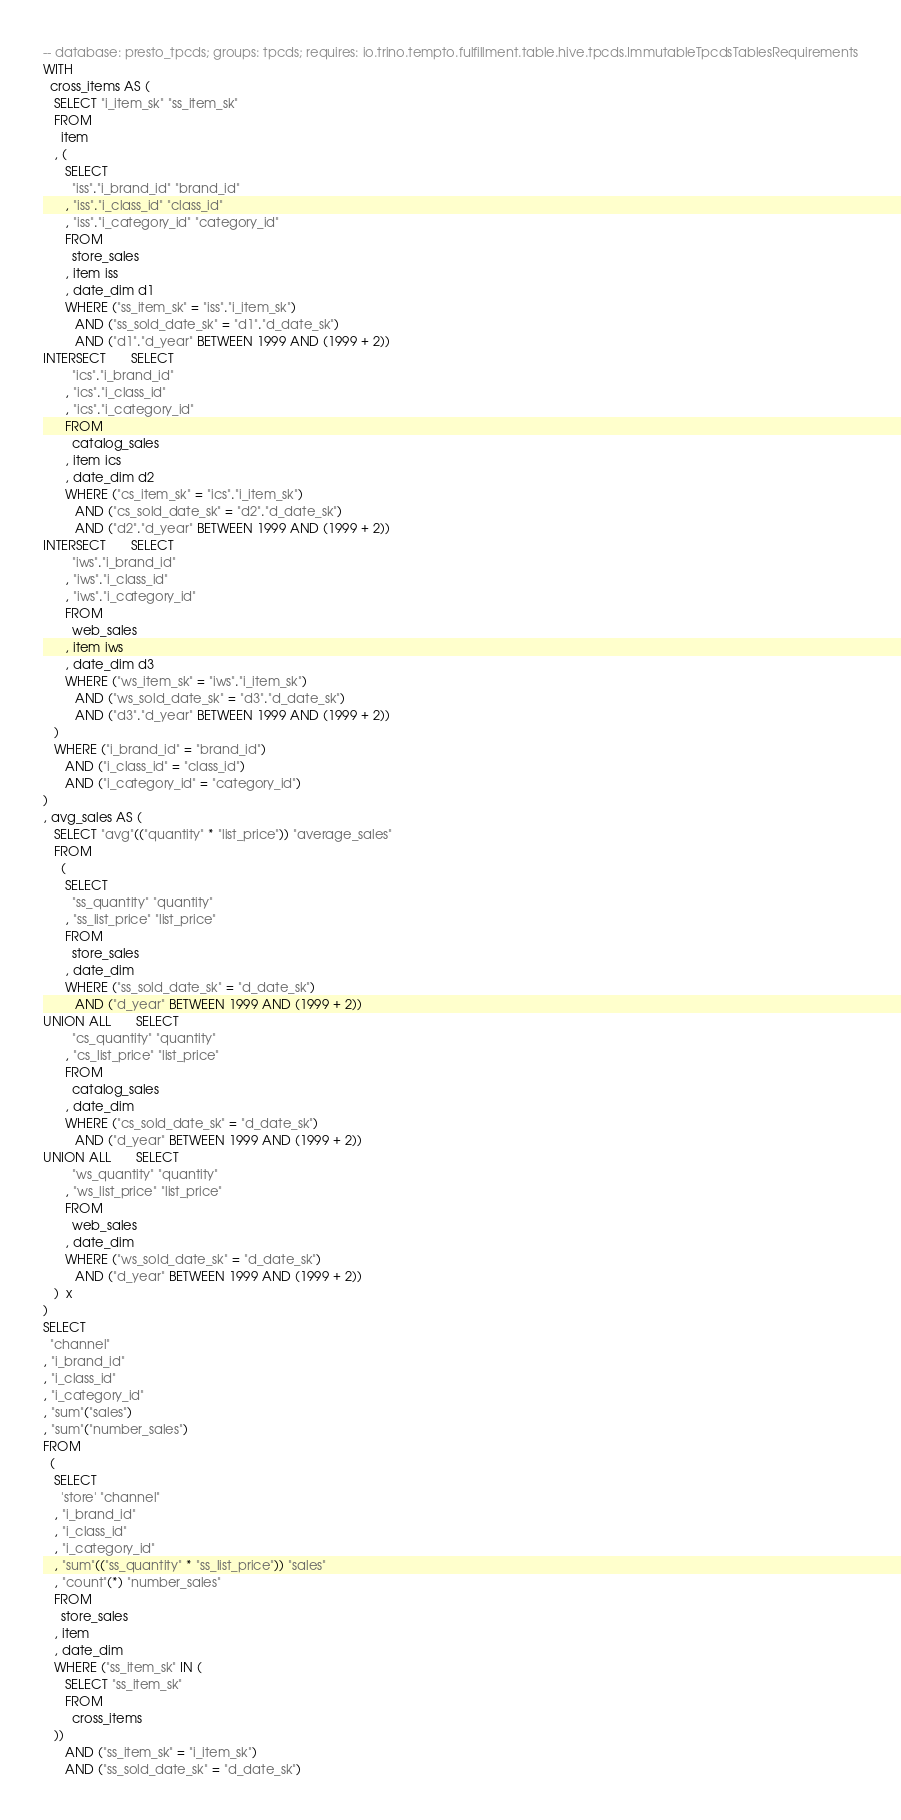Convert code to text. <code><loc_0><loc_0><loc_500><loc_500><_SQL_>-- database: presto_tpcds; groups: tpcds; requires: io.trino.tempto.fulfillment.table.hive.tpcds.ImmutableTpcdsTablesRequirements
WITH
  cross_items AS (
   SELECT "i_item_sk" "ss_item_sk"
   FROM
     item
   , (
      SELECT
        "iss"."i_brand_id" "brand_id"
      , "iss"."i_class_id" "class_id"
      , "iss"."i_category_id" "category_id"
      FROM
        store_sales
      , item iss
      , date_dim d1
      WHERE ("ss_item_sk" = "iss"."i_item_sk")
         AND ("ss_sold_date_sk" = "d1"."d_date_sk")
         AND ("d1"."d_year" BETWEEN 1999 AND (1999 + 2))
INTERSECT       SELECT
        "ics"."i_brand_id"
      , "ics"."i_class_id"
      , "ics"."i_category_id"
      FROM
        catalog_sales
      , item ics
      , date_dim d2
      WHERE ("cs_item_sk" = "ics"."i_item_sk")
         AND ("cs_sold_date_sk" = "d2"."d_date_sk")
         AND ("d2"."d_year" BETWEEN 1999 AND (1999 + 2))
INTERSECT       SELECT
        "iws"."i_brand_id"
      , "iws"."i_class_id"
      , "iws"."i_category_id"
      FROM
        web_sales
      , item iws
      , date_dim d3
      WHERE ("ws_item_sk" = "iws"."i_item_sk")
         AND ("ws_sold_date_sk" = "d3"."d_date_sk")
         AND ("d3"."d_year" BETWEEN 1999 AND (1999 + 2))
   )
   WHERE ("i_brand_id" = "brand_id")
      AND ("i_class_id" = "class_id")
      AND ("i_category_id" = "category_id")
)
, avg_sales AS (
   SELECT "avg"(("quantity" * "list_price")) "average_sales"
   FROM
     (
      SELECT
        "ss_quantity" "quantity"
      , "ss_list_price" "list_price"
      FROM
        store_sales
      , date_dim
      WHERE ("ss_sold_date_sk" = "d_date_sk")
         AND ("d_year" BETWEEN 1999 AND (1999 + 2))
UNION ALL       SELECT
        "cs_quantity" "quantity"
      , "cs_list_price" "list_price"
      FROM
        catalog_sales
      , date_dim
      WHERE ("cs_sold_date_sk" = "d_date_sk")
         AND ("d_year" BETWEEN 1999 AND (1999 + 2))
UNION ALL       SELECT
        "ws_quantity" "quantity"
      , "ws_list_price" "list_price"
      FROM
        web_sales
      , date_dim
      WHERE ("ws_sold_date_sk" = "d_date_sk")
         AND ("d_year" BETWEEN 1999 AND (1999 + 2))
   )  x
)
SELECT
  "channel"
, "i_brand_id"
, "i_class_id"
, "i_category_id"
, "sum"("sales")
, "sum"("number_sales")
FROM
  (
   SELECT
     'store' "channel"
   , "i_brand_id"
   , "i_class_id"
   , "i_category_id"
   , "sum"(("ss_quantity" * "ss_list_price")) "sales"
   , "count"(*) "number_sales"
   FROM
     store_sales
   , item
   , date_dim
   WHERE ("ss_item_sk" IN (
      SELECT "ss_item_sk"
      FROM
        cross_items
   ))
      AND ("ss_item_sk" = "i_item_sk")
      AND ("ss_sold_date_sk" = "d_date_sk")</code> 